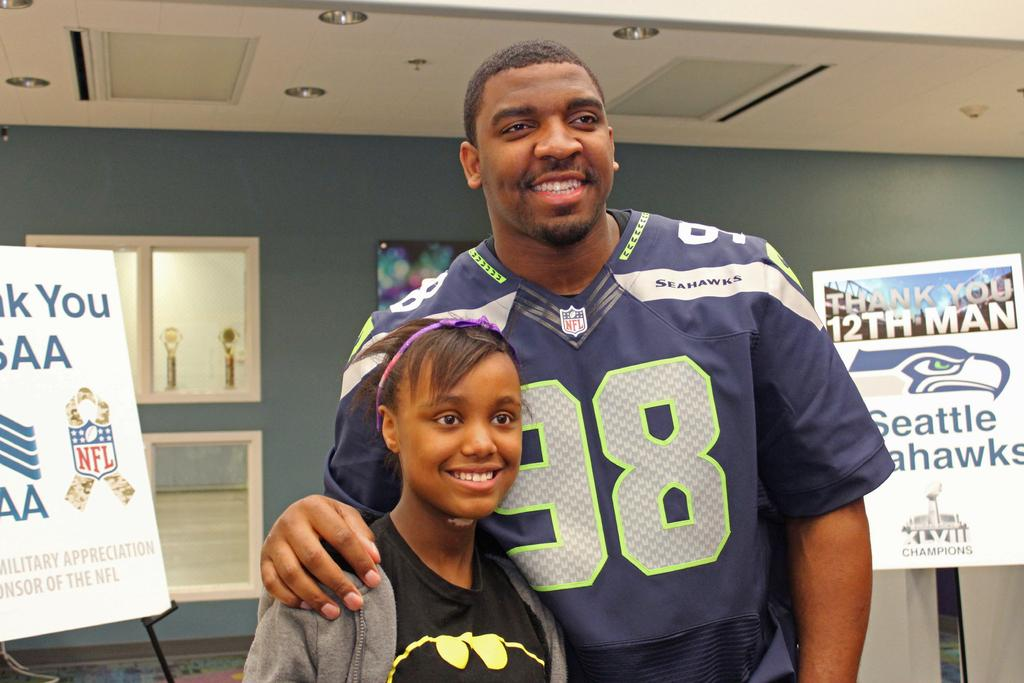<image>
Present a compact description of the photo's key features. a man with the number 98 on touching a girl's shoulder 